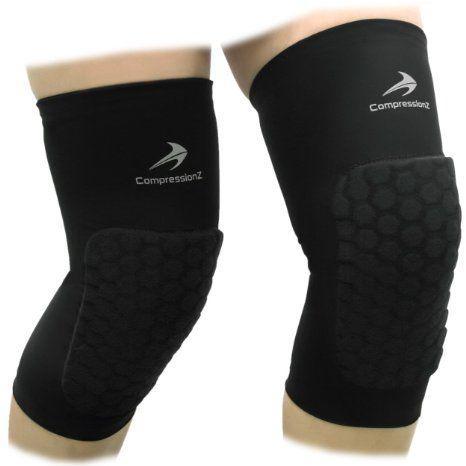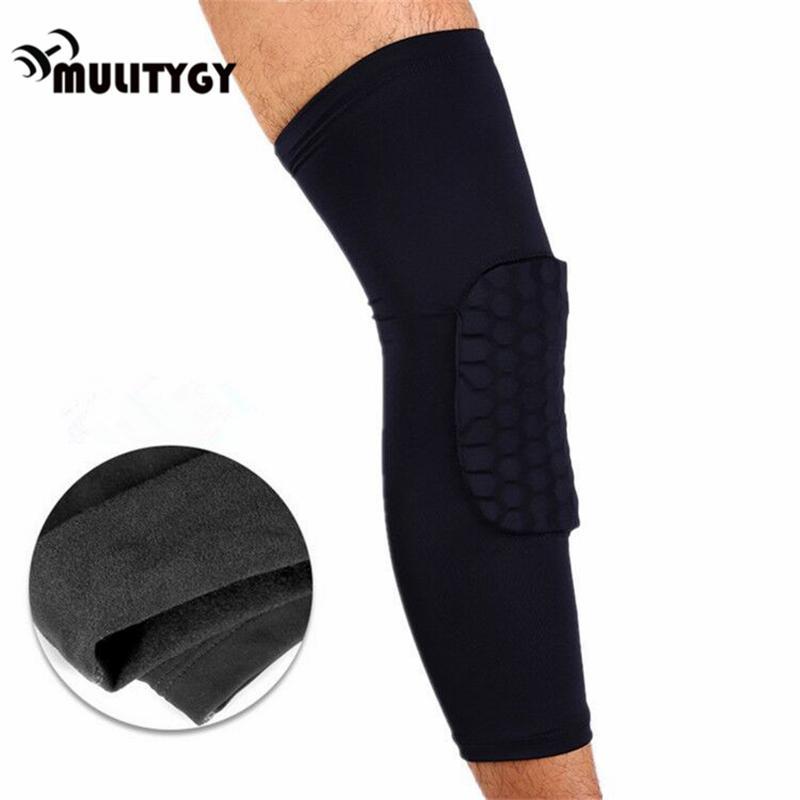The first image is the image on the left, the second image is the image on the right. Evaluate the accuracy of this statement regarding the images: "There is 1 or more joint wraps being displayed on a mannequin.". Is it true? Answer yes or no. No. The first image is the image on the left, the second image is the image on the right. Evaluate the accuracy of this statement regarding the images: "One of the knee braces has a small hole at the knee cap in an otherwise solid brace.". Is it true? Answer yes or no. No. 